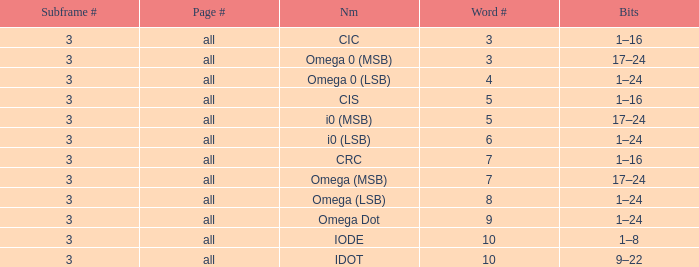What is the total word count with a subframe count greater than 3? None. 